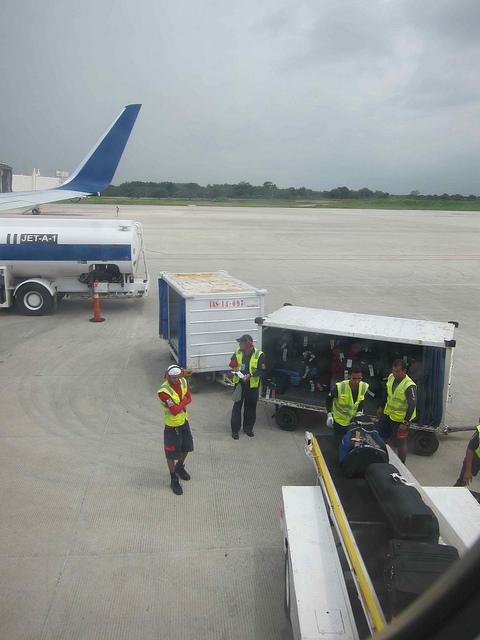What color is the bus?
Write a very short answer. White. Is it a sunny day?
Quick response, please. No. How many men are wearing vests?
Quick response, please. 4. Is this an airstrip?
Quick response, please. Yes. What is this object?
Answer briefly. Luggage cart. 